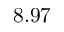<formula> <loc_0><loc_0><loc_500><loc_500>8 . 9 7</formula> 